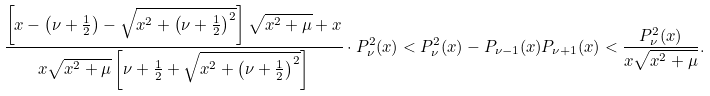Convert formula to latex. <formula><loc_0><loc_0><loc_500><loc_500>\frac { \left [ x - \left ( \nu + \frac { 1 } { 2 } \right ) - \sqrt { x ^ { 2 } + \left ( \nu + \frac { 1 } { 2 } \right ) ^ { 2 } } \right ] \sqrt { x ^ { 2 } + \mu } + x } { x \sqrt { x ^ { 2 } + \mu } \left [ \nu + \frac { 1 } { 2 } + \sqrt { x ^ { 2 } + \left ( \nu + \frac { 1 } { 2 } \right ) ^ { 2 } } \right ] } \cdot P _ { \nu } ^ { 2 } ( x ) < P _ { \nu } ^ { 2 } ( x ) - P _ { \nu - 1 } ( x ) P _ { \nu + 1 } ( x ) < \frac { P _ { \nu } ^ { 2 } ( x ) } { x \sqrt { x ^ { 2 } + \mu } } .</formula> 